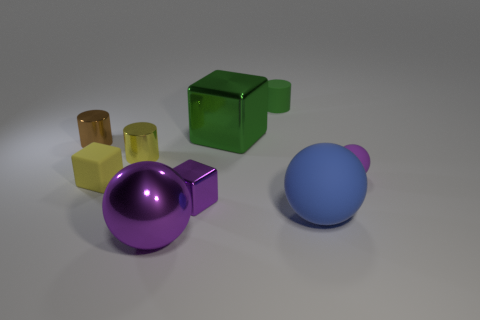There is a purple metal object in front of the small metal block; are there any balls right of it?
Make the answer very short. Yes. Is the large purple ball made of the same material as the tiny ball?
Offer a terse response. No. The tiny thing that is both right of the yellow matte cube and behind the yellow metal cylinder has what shape?
Provide a succinct answer. Cylinder. There is a matte thing that is to the left of the cube that is to the right of the purple metal block; what is its size?
Provide a short and direct response. Small. What number of small brown things have the same shape as the yellow metal object?
Provide a succinct answer. 1. Is the small rubber sphere the same color as the tiny rubber block?
Your answer should be compact. No. Is there anything else that has the same shape as the tiny brown metal thing?
Ensure brevity in your answer.  Yes. Are there any balls that have the same color as the small matte block?
Make the answer very short. No. Does the small cylinder that is behind the big green block have the same material as the small yellow thing that is on the right side of the tiny rubber cube?
Your response must be concise. No. The big metallic ball is what color?
Offer a very short reply. Purple. 